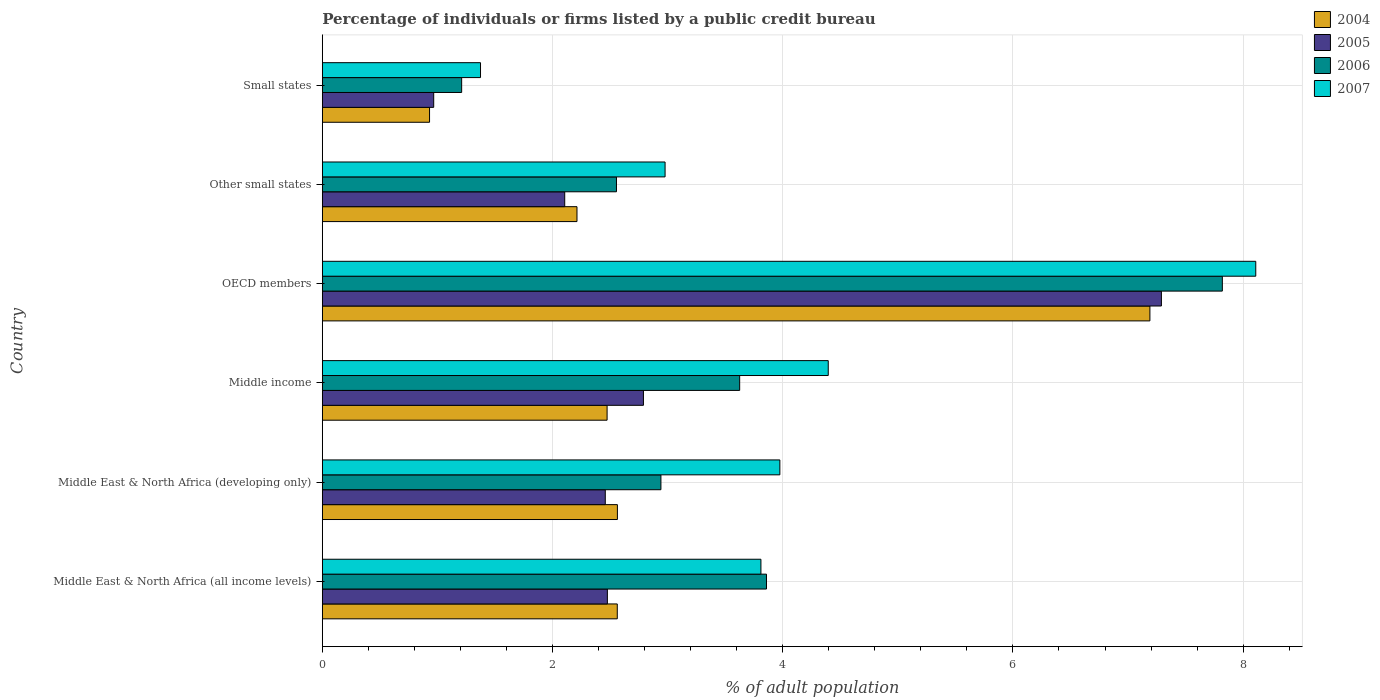How many different coloured bars are there?
Provide a short and direct response. 4. How many groups of bars are there?
Your answer should be compact. 6. Are the number of bars on each tick of the Y-axis equal?
Keep it short and to the point. Yes. How many bars are there on the 6th tick from the top?
Your response must be concise. 4. How many bars are there on the 4th tick from the bottom?
Provide a short and direct response. 4. In how many cases, is the number of bars for a given country not equal to the number of legend labels?
Make the answer very short. 0. What is the percentage of population listed by a public credit bureau in 2006 in Middle East & North Africa (all income levels)?
Give a very brief answer. 3.86. Across all countries, what is the maximum percentage of population listed by a public credit bureau in 2004?
Make the answer very short. 7.19. Across all countries, what is the minimum percentage of population listed by a public credit bureau in 2007?
Your answer should be very brief. 1.37. In which country was the percentage of population listed by a public credit bureau in 2007 maximum?
Offer a very short reply. OECD members. In which country was the percentage of population listed by a public credit bureau in 2005 minimum?
Provide a short and direct response. Small states. What is the total percentage of population listed by a public credit bureau in 2005 in the graph?
Your answer should be very brief. 18.09. What is the difference between the percentage of population listed by a public credit bureau in 2004 in Middle East & North Africa (all income levels) and that in Small states?
Keep it short and to the point. 1.63. What is the difference between the percentage of population listed by a public credit bureau in 2007 in Middle East & North Africa (all income levels) and the percentage of population listed by a public credit bureau in 2004 in Middle East & North Africa (developing only)?
Make the answer very short. 1.25. What is the average percentage of population listed by a public credit bureau in 2006 per country?
Your response must be concise. 3.67. What is the difference between the percentage of population listed by a public credit bureau in 2006 and percentage of population listed by a public credit bureau in 2007 in Small states?
Offer a very short reply. -0.16. What is the ratio of the percentage of population listed by a public credit bureau in 2005 in OECD members to that in Other small states?
Give a very brief answer. 3.46. Is the difference between the percentage of population listed by a public credit bureau in 2006 in Middle East & North Africa (all income levels) and Other small states greater than the difference between the percentage of population listed by a public credit bureau in 2007 in Middle East & North Africa (all income levels) and Other small states?
Provide a succinct answer. Yes. What is the difference between the highest and the second highest percentage of population listed by a public credit bureau in 2006?
Your response must be concise. 3.96. What is the difference between the highest and the lowest percentage of population listed by a public credit bureau in 2007?
Make the answer very short. 6.74. Is the sum of the percentage of population listed by a public credit bureau in 2006 in Middle income and OECD members greater than the maximum percentage of population listed by a public credit bureau in 2005 across all countries?
Offer a terse response. Yes. What does the 3rd bar from the bottom in Middle income represents?
Offer a terse response. 2006. Is it the case that in every country, the sum of the percentage of population listed by a public credit bureau in 2007 and percentage of population listed by a public credit bureau in 2005 is greater than the percentage of population listed by a public credit bureau in 2004?
Provide a succinct answer. Yes. Are all the bars in the graph horizontal?
Make the answer very short. Yes. What is the difference between two consecutive major ticks on the X-axis?
Provide a short and direct response. 2. Are the values on the major ticks of X-axis written in scientific E-notation?
Your answer should be very brief. No. Does the graph contain grids?
Make the answer very short. Yes. Where does the legend appear in the graph?
Offer a terse response. Top right. What is the title of the graph?
Provide a short and direct response. Percentage of individuals or firms listed by a public credit bureau. Does "1973" appear as one of the legend labels in the graph?
Offer a very short reply. No. What is the label or title of the X-axis?
Provide a succinct answer. % of adult population. What is the label or title of the Y-axis?
Your answer should be compact. Country. What is the % of adult population in 2004 in Middle East & North Africa (all income levels)?
Offer a very short reply. 2.56. What is the % of adult population in 2005 in Middle East & North Africa (all income levels)?
Keep it short and to the point. 2.48. What is the % of adult population of 2006 in Middle East & North Africa (all income levels)?
Offer a terse response. 3.86. What is the % of adult population in 2007 in Middle East & North Africa (all income levels)?
Give a very brief answer. 3.81. What is the % of adult population of 2004 in Middle East & North Africa (developing only)?
Ensure brevity in your answer.  2.56. What is the % of adult population of 2005 in Middle East & North Africa (developing only)?
Your answer should be compact. 2.46. What is the % of adult population in 2006 in Middle East & North Africa (developing only)?
Your answer should be very brief. 2.94. What is the % of adult population in 2007 in Middle East & North Africa (developing only)?
Your answer should be compact. 3.98. What is the % of adult population in 2004 in Middle income?
Your answer should be compact. 2.47. What is the % of adult population in 2005 in Middle income?
Offer a very short reply. 2.79. What is the % of adult population in 2006 in Middle income?
Keep it short and to the point. 3.63. What is the % of adult population of 2007 in Middle income?
Keep it short and to the point. 4.4. What is the % of adult population in 2004 in OECD members?
Your answer should be very brief. 7.19. What is the % of adult population of 2005 in OECD members?
Keep it short and to the point. 7.29. What is the % of adult population of 2006 in OECD members?
Your response must be concise. 7.82. What is the % of adult population in 2007 in OECD members?
Your answer should be compact. 8.11. What is the % of adult population of 2004 in Other small states?
Offer a terse response. 2.21. What is the % of adult population of 2005 in Other small states?
Provide a short and direct response. 2.11. What is the % of adult population in 2006 in Other small states?
Provide a succinct answer. 2.56. What is the % of adult population of 2007 in Other small states?
Provide a succinct answer. 2.98. What is the % of adult population in 2004 in Small states?
Give a very brief answer. 0.93. What is the % of adult population of 2005 in Small states?
Your response must be concise. 0.97. What is the % of adult population in 2006 in Small states?
Provide a succinct answer. 1.21. What is the % of adult population in 2007 in Small states?
Your response must be concise. 1.37. Across all countries, what is the maximum % of adult population of 2004?
Make the answer very short. 7.19. Across all countries, what is the maximum % of adult population of 2005?
Your answer should be compact. 7.29. Across all countries, what is the maximum % of adult population in 2006?
Your answer should be very brief. 7.82. Across all countries, what is the maximum % of adult population in 2007?
Keep it short and to the point. 8.11. Across all countries, what is the minimum % of adult population in 2004?
Offer a very short reply. 0.93. Across all countries, what is the minimum % of adult population of 2005?
Ensure brevity in your answer.  0.97. Across all countries, what is the minimum % of adult population in 2006?
Offer a terse response. 1.21. Across all countries, what is the minimum % of adult population in 2007?
Offer a very short reply. 1.37. What is the total % of adult population in 2004 in the graph?
Your answer should be compact. 17.93. What is the total % of adult population in 2005 in the graph?
Make the answer very short. 18.09. What is the total % of adult population in 2006 in the graph?
Provide a succinct answer. 22.01. What is the total % of adult population in 2007 in the graph?
Give a very brief answer. 24.64. What is the difference between the % of adult population of 2004 in Middle East & North Africa (all income levels) and that in Middle East & North Africa (developing only)?
Your answer should be compact. -0. What is the difference between the % of adult population in 2005 in Middle East & North Africa (all income levels) and that in Middle East & North Africa (developing only)?
Offer a terse response. 0.02. What is the difference between the % of adult population of 2006 in Middle East & North Africa (all income levels) and that in Middle East & North Africa (developing only)?
Provide a succinct answer. 0.92. What is the difference between the % of adult population in 2007 in Middle East & North Africa (all income levels) and that in Middle East & North Africa (developing only)?
Your answer should be very brief. -0.16. What is the difference between the % of adult population of 2004 in Middle East & North Africa (all income levels) and that in Middle income?
Keep it short and to the point. 0.09. What is the difference between the % of adult population in 2005 in Middle East & North Africa (all income levels) and that in Middle income?
Keep it short and to the point. -0.31. What is the difference between the % of adult population of 2006 in Middle East & North Africa (all income levels) and that in Middle income?
Provide a short and direct response. 0.23. What is the difference between the % of adult population in 2007 in Middle East & North Africa (all income levels) and that in Middle income?
Provide a succinct answer. -0.58. What is the difference between the % of adult population in 2004 in Middle East & North Africa (all income levels) and that in OECD members?
Provide a succinct answer. -4.63. What is the difference between the % of adult population in 2005 in Middle East & North Africa (all income levels) and that in OECD members?
Provide a short and direct response. -4.81. What is the difference between the % of adult population of 2006 in Middle East & North Africa (all income levels) and that in OECD members?
Provide a short and direct response. -3.96. What is the difference between the % of adult population in 2007 in Middle East & North Africa (all income levels) and that in OECD members?
Keep it short and to the point. -4.3. What is the difference between the % of adult population in 2004 in Middle East & North Africa (all income levels) and that in Other small states?
Your response must be concise. 0.35. What is the difference between the % of adult population of 2005 in Middle East & North Africa (all income levels) and that in Other small states?
Offer a very short reply. 0.37. What is the difference between the % of adult population in 2006 in Middle East & North Africa (all income levels) and that in Other small states?
Offer a terse response. 1.3. What is the difference between the % of adult population in 2007 in Middle East & North Africa (all income levels) and that in Other small states?
Provide a short and direct response. 0.83. What is the difference between the % of adult population of 2004 in Middle East & North Africa (all income levels) and that in Small states?
Offer a very short reply. 1.63. What is the difference between the % of adult population in 2005 in Middle East & North Africa (all income levels) and that in Small states?
Your response must be concise. 1.51. What is the difference between the % of adult population in 2006 in Middle East & North Africa (all income levels) and that in Small states?
Make the answer very short. 2.65. What is the difference between the % of adult population of 2007 in Middle East & North Africa (all income levels) and that in Small states?
Keep it short and to the point. 2.44. What is the difference between the % of adult population in 2004 in Middle East & North Africa (developing only) and that in Middle income?
Offer a very short reply. 0.09. What is the difference between the % of adult population in 2005 in Middle East & North Africa (developing only) and that in Middle income?
Offer a terse response. -0.33. What is the difference between the % of adult population in 2006 in Middle East & North Africa (developing only) and that in Middle income?
Keep it short and to the point. -0.68. What is the difference between the % of adult population in 2007 in Middle East & North Africa (developing only) and that in Middle income?
Keep it short and to the point. -0.42. What is the difference between the % of adult population of 2004 in Middle East & North Africa (developing only) and that in OECD members?
Make the answer very short. -4.63. What is the difference between the % of adult population of 2005 in Middle East & North Africa (developing only) and that in OECD members?
Offer a terse response. -4.83. What is the difference between the % of adult population of 2006 in Middle East & North Africa (developing only) and that in OECD members?
Make the answer very short. -4.88. What is the difference between the % of adult population of 2007 in Middle East & North Africa (developing only) and that in OECD members?
Ensure brevity in your answer.  -4.13. What is the difference between the % of adult population of 2004 in Middle East & North Africa (developing only) and that in Other small states?
Ensure brevity in your answer.  0.35. What is the difference between the % of adult population of 2005 in Middle East & North Africa (developing only) and that in Other small states?
Offer a very short reply. 0.35. What is the difference between the % of adult population of 2006 in Middle East & North Africa (developing only) and that in Other small states?
Keep it short and to the point. 0.39. What is the difference between the % of adult population of 2007 in Middle East & North Africa (developing only) and that in Other small states?
Provide a short and direct response. 1. What is the difference between the % of adult population of 2004 in Middle East & North Africa (developing only) and that in Small states?
Keep it short and to the point. 1.63. What is the difference between the % of adult population of 2005 in Middle East & North Africa (developing only) and that in Small states?
Give a very brief answer. 1.49. What is the difference between the % of adult population of 2006 in Middle East & North Africa (developing only) and that in Small states?
Provide a succinct answer. 1.73. What is the difference between the % of adult population of 2007 in Middle East & North Africa (developing only) and that in Small states?
Offer a terse response. 2.6. What is the difference between the % of adult population in 2004 in Middle income and that in OECD members?
Offer a terse response. -4.72. What is the difference between the % of adult population in 2005 in Middle income and that in OECD members?
Offer a terse response. -4.5. What is the difference between the % of adult population of 2006 in Middle income and that in OECD members?
Provide a succinct answer. -4.19. What is the difference between the % of adult population in 2007 in Middle income and that in OECD members?
Provide a short and direct response. -3.71. What is the difference between the % of adult population of 2004 in Middle income and that in Other small states?
Provide a succinct answer. 0.26. What is the difference between the % of adult population in 2005 in Middle income and that in Other small states?
Offer a terse response. 0.68. What is the difference between the % of adult population in 2006 in Middle income and that in Other small states?
Make the answer very short. 1.07. What is the difference between the % of adult population in 2007 in Middle income and that in Other small states?
Offer a very short reply. 1.42. What is the difference between the % of adult population in 2004 in Middle income and that in Small states?
Make the answer very short. 1.54. What is the difference between the % of adult population in 2005 in Middle income and that in Small states?
Make the answer very short. 1.82. What is the difference between the % of adult population of 2006 in Middle income and that in Small states?
Provide a succinct answer. 2.42. What is the difference between the % of adult population of 2007 in Middle income and that in Small states?
Offer a very short reply. 3.02. What is the difference between the % of adult population in 2004 in OECD members and that in Other small states?
Your response must be concise. 4.98. What is the difference between the % of adult population of 2005 in OECD members and that in Other small states?
Provide a short and direct response. 5.18. What is the difference between the % of adult population of 2006 in OECD members and that in Other small states?
Offer a very short reply. 5.26. What is the difference between the % of adult population of 2007 in OECD members and that in Other small states?
Offer a terse response. 5.13. What is the difference between the % of adult population of 2004 in OECD members and that in Small states?
Offer a very short reply. 6.26. What is the difference between the % of adult population of 2005 in OECD members and that in Small states?
Make the answer very short. 6.32. What is the difference between the % of adult population in 2006 in OECD members and that in Small states?
Your answer should be very brief. 6.61. What is the difference between the % of adult population of 2007 in OECD members and that in Small states?
Make the answer very short. 6.74. What is the difference between the % of adult population in 2004 in Other small states and that in Small states?
Offer a terse response. 1.28. What is the difference between the % of adult population of 2005 in Other small states and that in Small states?
Offer a very short reply. 1.14. What is the difference between the % of adult population in 2006 in Other small states and that in Small states?
Keep it short and to the point. 1.34. What is the difference between the % of adult population in 2007 in Other small states and that in Small states?
Provide a short and direct response. 1.6. What is the difference between the % of adult population of 2004 in Middle East & North Africa (all income levels) and the % of adult population of 2005 in Middle East & North Africa (developing only)?
Your response must be concise. 0.1. What is the difference between the % of adult population in 2004 in Middle East & North Africa (all income levels) and the % of adult population in 2006 in Middle East & North Africa (developing only)?
Ensure brevity in your answer.  -0.38. What is the difference between the % of adult population of 2004 in Middle East & North Africa (all income levels) and the % of adult population of 2007 in Middle East & North Africa (developing only)?
Keep it short and to the point. -1.41. What is the difference between the % of adult population in 2005 in Middle East & North Africa (all income levels) and the % of adult population in 2006 in Middle East & North Africa (developing only)?
Your answer should be compact. -0.47. What is the difference between the % of adult population of 2005 in Middle East & North Africa (all income levels) and the % of adult population of 2007 in Middle East & North Africa (developing only)?
Provide a short and direct response. -1.5. What is the difference between the % of adult population of 2006 in Middle East & North Africa (all income levels) and the % of adult population of 2007 in Middle East & North Africa (developing only)?
Provide a succinct answer. -0.12. What is the difference between the % of adult population of 2004 in Middle East & North Africa (all income levels) and the % of adult population of 2005 in Middle income?
Ensure brevity in your answer.  -0.23. What is the difference between the % of adult population in 2004 in Middle East & North Africa (all income levels) and the % of adult population in 2006 in Middle income?
Ensure brevity in your answer.  -1.06. What is the difference between the % of adult population of 2004 in Middle East & North Africa (all income levels) and the % of adult population of 2007 in Middle income?
Keep it short and to the point. -1.83. What is the difference between the % of adult population of 2005 in Middle East & North Africa (all income levels) and the % of adult population of 2006 in Middle income?
Make the answer very short. -1.15. What is the difference between the % of adult population in 2005 in Middle East & North Africa (all income levels) and the % of adult population in 2007 in Middle income?
Keep it short and to the point. -1.92. What is the difference between the % of adult population of 2006 in Middle East & North Africa (all income levels) and the % of adult population of 2007 in Middle income?
Keep it short and to the point. -0.54. What is the difference between the % of adult population in 2004 in Middle East & North Africa (all income levels) and the % of adult population in 2005 in OECD members?
Give a very brief answer. -4.73. What is the difference between the % of adult population of 2004 in Middle East & North Africa (all income levels) and the % of adult population of 2006 in OECD members?
Your answer should be compact. -5.26. What is the difference between the % of adult population of 2004 in Middle East & North Africa (all income levels) and the % of adult population of 2007 in OECD members?
Provide a short and direct response. -5.55. What is the difference between the % of adult population of 2005 in Middle East & North Africa (all income levels) and the % of adult population of 2006 in OECD members?
Provide a short and direct response. -5.34. What is the difference between the % of adult population in 2005 in Middle East & North Africa (all income levels) and the % of adult population in 2007 in OECD members?
Offer a terse response. -5.63. What is the difference between the % of adult population of 2006 in Middle East & North Africa (all income levels) and the % of adult population of 2007 in OECD members?
Your response must be concise. -4.25. What is the difference between the % of adult population of 2004 in Middle East & North Africa (all income levels) and the % of adult population of 2005 in Other small states?
Ensure brevity in your answer.  0.46. What is the difference between the % of adult population in 2004 in Middle East & North Africa (all income levels) and the % of adult population in 2006 in Other small states?
Your answer should be very brief. 0.01. What is the difference between the % of adult population of 2004 in Middle East & North Africa (all income levels) and the % of adult population of 2007 in Other small states?
Your answer should be very brief. -0.42. What is the difference between the % of adult population of 2005 in Middle East & North Africa (all income levels) and the % of adult population of 2006 in Other small states?
Your answer should be very brief. -0.08. What is the difference between the % of adult population of 2005 in Middle East & North Africa (all income levels) and the % of adult population of 2007 in Other small states?
Give a very brief answer. -0.5. What is the difference between the % of adult population of 2006 in Middle East & North Africa (all income levels) and the % of adult population of 2007 in Other small states?
Ensure brevity in your answer.  0.88. What is the difference between the % of adult population in 2004 in Middle East & North Africa (all income levels) and the % of adult population in 2005 in Small states?
Your response must be concise. 1.59. What is the difference between the % of adult population in 2004 in Middle East & North Africa (all income levels) and the % of adult population in 2006 in Small states?
Your answer should be very brief. 1.35. What is the difference between the % of adult population of 2004 in Middle East & North Africa (all income levels) and the % of adult population of 2007 in Small states?
Keep it short and to the point. 1.19. What is the difference between the % of adult population of 2005 in Middle East & North Africa (all income levels) and the % of adult population of 2006 in Small states?
Offer a very short reply. 1.27. What is the difference between the % of adult population of 2005 in Middle East & North Africa (all income levels) and the % of adult population of 2007 in Small states?
Offer a very short reply. 1.1. What is the difference between the % of adult population in 2006 in Middle East & North Africa (all income levels) and the % of adult population in 2007 in Small states?
Your response must be concise. 2.48. What is the difference between the % of adult population in 2004 in Middle East & North Africa (developing only) and the % of adult population in 2005 in Middle income?
Keep it short and to the point. -0.23. What is the difference between the % of adult population in 2004 in Middle East & North Africa (developing only) and the % of adult population in 2006 in Middle income?
Your answer should be compact. -1.06. What is the difference between the % of adult population in 2004 in Middle East & North Africa (developing only) and the % of adult population in 2007 in Middle income?
Provide a succinct answer. -1.83. What is the difference between the % of adult population in 2005 in Middle East & North Africa (developing only) and the % of adult population in 2006 in Middle income?
Your response must be concise. -1.17. What is the difference between the % of adult population of 2005 in Middle East & North Africa (developing only) and the % of adult population of 2007 in Middle income?
Offer a terse response. -1.94. What is the difference between the % of adult population of 2006 in Middle East & North Africa (developing only) and the % of adult population of 2007 in Middle income?
Your response must be concise. -1.45. What is the difference between the % of adult population of 2004 in Middle East & North Africa (developing only) and the % of adult population of 2005 in OECD members?
Provide a short and direct response. -4.73. What is the difference between the % of adult population in 2004 in Middle East & North Africa (developing only) and the % of adult population in 2006 in OECD members?
Your answer should be compact. -5.26. What is the difference between the % of adult population of 2004 in Middle East & North Africa (developing only) and the % of adult population of 2007 in OECD members?
Ensure brevity in your answer.  -5.55. What is the difference between the % of adult population of 2005 in Middle East & North Africa (developing only) and the % of adult population of 2006 in OECD members?
Keep it short and to the point. -5.36. What is the difference between the % of adult population of 2005 in Middle East & North Africa (developing only) and the % of adult population of 2007 in OECD members?
Make the answer very short. -5.65. What is the difference between the % of adult population in 2006 in Middle East & North Africa (developing only) and the % of adult population in 2007 in OECD members?
Provide a short and direct response. -5.17. What is the difference between the % of adult population in 2004 in Middle East & North Africa (developing only) and the % of adult population in 2005 in Other small states?
Make the answer very short. 0.46. What is the difference between the % of adult population of 2004 in Middle East & North Africa (developing only) and the % of adult population of 2006 in Other small states?
Ensure brevity in your answer.  0.01. What is the difference between the % of adult population of 2004 in Middle East & North Africa (developing only) and the % of adult population of 2007 in Other small states?
Offer a very short reply. -0.41. What is the difference between the % of adult population in 2005 in Middle East & North Africa (developing only) and the % of adult population in 2006 in Other small states?
Offer a terse response. -0.1. What is the difference between the % of adult population in 2005 in Middle East & North Africa (developing only) and the % of adult population in 2007 in Other small states?
Your response must be concise. -0.52. What is the difference between the % of adult population of 2006 in Middle East & North Africa (developing only) and the % of adult population of 2007 in Other small states?
Provide a succinct answer. -0.04. What is the difference between the % of adult population in 2004 in Middle East & North Africa (developing only) and the % of adult population in 2005 in Small states?
Offer a very short reply. 1.6. What is the difference between the % of adult population of 2004 in Middle East & North Africa (developing only) and the % of adult population of 2006 in Small states?
Offer a terse response. 1.35. What is the difference between the % of adult population in 2004 in Middle East & North Africa (developing only) and the % of adult population in 2007 in Small states?
Keep it short and to the point. 1.19. What is the difference between the % of adult population in 2005 in Middle East & North Africa (developing only) and the % of adult population in 2006 in Small states?
Provide a short and direct response. 1.25. What is the difference between the % of adult population of 2005 in Middle East & North Africa (developing only) and the % of adult population of 2007 in Small states?
Give a very brief answer. 1.08. What is the difference between the % of adult population of 2006 in Middle East & North Africa (developing only) and the % of adult population of 2007 in Small states?
Give a very brief answer. 1.57. What is the difference between the % of adult population of 2004 in Middle income and the % of adult population of 2005 in OECD members?
Give a very brief answer. -4.82. What is the difference between the % of adult population in 2004 in Middle income and the % of adult population in 2006 in OECD members?
Offer a very short reply. -5.35. What is the difference between the % of adult population of 2004 in Middle income and the % of adult population of 2007 in OECD members?
Provide a short and direct response. -5.64. What is the difference between the % of adult population in 2005 in Middle income and the % of adult population in 2006 in OECD members?
Your answer should be very brief. -5.03. What is the difference between the % of adult population of 2005 in Middle income and the % of adult population of 2007 in OECD members?
Your response must be concise. -5.32. What is the difference between the % of adult population in 2006 in Middle income and the % of adult population in 2007 in OECD members?
Provide a short and direct response. -4.48. What is the difference between the % of adult population of 2004 in Middle income and the % of adult population of 2005 in Other small states?
Your answer should be compact. 0.37. What is the difference between the % of adult population of 2004 in Middle income and the % of adult population of 2006 in Other small states?
Make the answer very short. -0.08. What is the difference between the % of adult population in 2004 in Middle income and the % of adult population in 2007 in Other small states?
Make the answer very short. -0.5. What is the difference between the % of adult population of 2005 in Middle income and the % of adult population of 2006 in Other small states?
Keep it short and to the point. 0.23. What is the difference between the % of adult population of 2005 in Middle income and the % of adult population of 2007 in Other small states?
Keep it short and to the point. -0.19. What is the difference between the % of adult population in 2006 in Middle income and the % of adult population in 2007 in Other small states?
Offer a terse response. 0.65. What is the difference between the % of adult population of 2004 in Middle income and the % of adult population of 2005 in Small states?
Keep it short and to the point. 1.51. What is the difference between the % of adult population of 2004 in Middle income and the % of adult population of 2006 in Small states?
Provide a succinct answer. 1.26. What is the difference between the % of adult population of 2004 in Middle income and the % of adult population of 2007 in Small states?
Give a very brief answer. 1.1. What is the difference between the % of adult population of 2005 in Middle income and the % of adult population of 2006 in Small states?
Ensure brevity in your answer.  1.58. What is the difference between the % of adult population in 2005 in Middle income and the % of adult population in 2007 in Small states?
Make the answer very short. 1.42. What is the difference between the % of adult population in 2006 in Middle income and the % of adult population in 2007 in Small states?
Your answer should be very brief. 2.25. What is the difference between the % of adult population in 2004 in OECD members and the % of adult population in 2005 in Other small states?
Offer a terse response. 5.08. What is the difference between the % of adult population in 2004 in OECD members and the % of adult population in 2006 in Other small states?
Provide a succinct answer. 4.63. What is the difference between the % of adult population of 2004 in OECD members and the % of adult population of 2007 in Other small states?
Ensure brevity in your answer.  4.21. What is the difference between the % of adult population in 2005 in OECD members and the % of adult population in 2006 in Other small states?
Provide a short and direct response. 4.73. What is the difference between the % of adult population of 2005 in OECD members and the % of adult population of 2007 in Other small states?
Give a very brief answer. 4.31. What is the difference between the % of adult population of 2006 in OECD members and the % of adult population of 2007 in Other small states?
Your answer should be compact. 4.84. What is the difference between the % of adult population in 2004 in OECD members and the % of adult population in 2005 in Small states?
Your response must be concise. 6.22. What is the difference between the % of adult population of 2004 in OECD members and the % of adult population of 2006 in Small states?
Ensure brevity in your answer.  5.98. What is the difference between the % of adult population of 2004 in OECD members and the % of adult population of 2007 in Small states?
Provide a succinct answer. 5.82. What is the difference between the % of adult population in 2005 in OECD members and the % of adult population in 2006 in Small states?
Your answer should be compact. 6.08. What is the difference between the % of adult population of 2005 in OECD members and the % of adult population of 2007 in Small states?
Provide a short and direct response. 5.92. What is the difference between the % of adult population in 2006 in OECD members and the % of adult population in 2007 in Small states?
Provide a succinct answer. 6.45. What is the difference between the % of adult population in 2004 in Other small states and the % of adult population in 2005 in Small states?
Your answer should be very brief. 1.24. What is the difference between the % of adult population in 2004 in Other small states and the % of adult population in 2006 in Small states?
Ensure brevity in your answer.  1. What is the difference between the % of adult population in 2004 in Other small states and the % of adult population in 2007 in Small states?
Provide a short and direct response. 0.84. What is the difference between the % of adult population of 2005 in Other small states and the % of adult population of 2006 in Small states?
Make the answer very short. 0.9. What is the difference between the % of adult population of 2005 in Other small states and the % of adult population of 2007 in Small states?
Ensure brevity in your answer.  0.73. What is the difference between the % of adult population of 2006 in Other small states and the % of adult population of 2007 in Small states?
Keep it short and to the point. 1.18. What is the average % of adult population of 2004 per country?
Give a very brief answer. 2.99. What is the average % of adult population in 2005 per country?
Provide a short and direct response. 3.01. What is the average % of adult population in 2006 per country?
Offer a very short reply. 3.67. What is the average % of adult population in 2007 per country?
Your answer should be compact. 4.11. What is the difference between the % of adult population of 2004 and % of adult population of 2005 in Middle East & North Africa (all income levels)?
Offer a terse response. 0.09. What is the difference between the % of adult population in 2004 and % of adult population in 2006 in Middle East & North Africa (all income levels)?
Provide a short and direct response. -1.3. What is the difference between the % of adult population of 2004 and % of adult population of 2007 in Middle East & North Africa (all income levels)?
Keep it short and to the point. -1.25. What is the difference between the % of adult population of 2005 and % of adult population of 2006 in Middle East & North Africa (all income levels)?
Provide a succinct answer. -1.38. What is the difference between the % of adult population in 2005 and % of adult population in 2007 in Middle East & North Africa (all income levels)?
Make the answer very short. -1.33. What is the difference between the % of adult population in 2006 and % of adult population in 2007 in Middle East & North Africa (all income levels)?
Keep it short and to the point. 0.05. What is the difference between the % of adult population of 2004 and % of adult population of 2005 in Middle East & North Africa (developing only)?
Your answer should be very brief. 0.11. What is the difference between the % of adult population in 2004 and % of adult population in 2006 in Middle East & North Africa (developing only)?
Provide a succinct answer. -0.38. What is the difference between the % of adult population in 2004 and % of adult population in 2007 in Middle East & North Africa (developing only)?
Keep it short and to the point. -1.41. What is the difference between the % of adult population in 2005 and % of adult population in 2006 in Middle East & North Africa (developing only)?
Offer a terse response. -0.48. What is the difference between the % of adult population in 2005 and % of adult population in 2007 in Middle East & North Africa (developing only)?
Provide a succinct answer. -1.52. What is the difference between the % of adult population of 2006 and % of adult population of 2007 in Middle East & North Africa (developing only)?
Offer a very short reply. -1.03. What is the difference between the % of adult population of 2004 and % of adult population of 2005 in Middle income?
Keep it short and to the point. -0.32. What is the difference between the % of adult population of 2004 and % of adult population of 2006 in Middle income?
Make the answer very short. -1.15. What is the difference between the % of adult population of 2004 and % of adult population of 2007 in Middle income?
Your answer should be compact. -1.92. What is the difference between the % of adult population in 2005 and % of adult population in 2006 in Middle income?
Provide a short and direct response. -0.84. What is the difference between the % of adult population in 2005 and % of adult population in 2007 in Middle income?
Ensure brevity in your answer.  -1.61. What is the difference between the % of adult population in 2006 and % of adult population in 2007 in Middle income?
Your answer should be very brief. -0.77. What is the difference between the % of adult population of 2004 and % of adult population of 2006 in OECD members?
Make the answer very short. -0.63. What is the difference between the % of adult population in 2004 and % of adult population in 2007 in OECD members?
Make the answer very short. -0.92. What is the difference between the % of adult population in 2005 and % of adult population in 2006 in OECD members?
Give a very brief answer. -0.53. What is the difference between the % of adult population of 2005 and % of adult population of 2007 in OECD members?
Offer a terse response. -0.82. What is the difference between the % of adult population in 2006 and % of adult population in 2007 in OECD members?
Give a very brief answer. -0.29. What is the difference between the % of adult population of 2004 and % of adult population of 2005 in Other small states?
Keep it short and to the point. 0.11. What is the difference between the % of adult population of 2004 and % of adult population of 2006 in Other small states?
Provide a short and direct response. -0.34. What is the difference between the % of adult population in 2004 and % of adult population in 2007 in Other small states?
Give a very brief answer. -0.77. What is the difference between the % of adult population of 2005 and % of adult population of 2006 in Other small states?
Your response must be concise. -0.45. What is the difference between the % of adult population of 2005 and % of adult population of 2007 in Other small states?
Ensure brevity in your answer.  -0.87. What is the difference between the % of adult population of 2006 and % of adult population of 2007 in Other small states?
Offer a terse response. -0.42. What is the difference between the % of adult population in 2004 and % of adult population in 2005 in Small states?
Ensure brevity in your answer.  -0.04. What is the difference between the % of adult population in 2004 and % of adult population in 2006 in Small states?
Your answer should be very brief. -0.28. What is the difference between the % of adult population in 2004 and % of adult population in 2007 in Small states?
Offer a terse response. -0.44. What is the difference between the % of adult population of 2005 and % of adult population of 2006 in Small states?
Provide a succinct answer. -0.24. What is the difference between the % of adult population of 2005 and % of adult population of 2007 in Small states?
Provide a succinct answer. -0.41. What is the difference between the % of adult population in 2006 and % of adult population in 2007 in Small states?
Keep it short and to the point. -0.16. What is the ratio of the % of adult population of 2004 in Middle East & North Africa (all income levels) to that in Middle East & North Africa (developing only)?
Give a very brief answer. 1. What is the ratio of the % of adult population in 2005 in Middle East & North Africa (all income levels) to that in Middle East & North Africa (developing only)?
Make the answer very short. 1.01. What is the ratio of the % of adult population in 2006 in Middle East & North Africa (all income levels) to that in Middle East & North Africa (developing only)?
Your response must be concise. 1.31. What is the ratio of the % of adult population in 2007 in Middle East & North Africa (all income levels) to that in Middle East & North Africa (developing only)?
Offer a very short reply. 0.96. What is the ratio of the % of adult population in 2004 in Middle East & North Africa (all income levels) to that in Middle income?
Ensure brevity in your answer.  1.04. What is the ratio of the % of adult population of 2005 in Middle East & North Africa (all income levels) to that in Middle income?
Provide a short and direct response. 0.89. What is the ratio of the % of adult population in 2006 in Middle East & North Africa (all income levels) to that in Middle income?
Give a very brief answer. 1.06. What is the ratio of the % of adult population of 2007 in Middle East & North Africa (all income levels) to that in Middle income?
Your response must be concise. 0.87. What is the ratio of the % of adult population of 2004 in Middle East & North Africa (all income levels) to that in OECD members?
Offer a terse response. 0.36. What is the ratio of the % of adult population in 2005 in Middle East & North Africa (all income levels) to that in OECD members?
Your answer should be very brief. 0.34. What is the ratio of the % of adult population in 2006 in Middle East & North Africa (all income levels) to that in OECD members?
Keep it short and to the point. 0.49. What is the ratio of the % of adult population in 2007 in Middle East & North Africa (all income levels) to that in OECD members?
Provide a short and direct response. 0.47. What is the ratio of the % of adult population of 2004 in Middle East & North Africa (all income levels) to that in Other small states?
Your answer should be very brief. 1.16. What is the ratio of the % of adult population in 2005 in Middle East & North Africa (all income levels) to that in Other small states?
Offer a terse response. 1.18. What is the ratio of the % of adult population in 2006 in Middle East & North Africa (all income levels) to that in Other small states?
Keep it short and to the point. 1.51. What is the ratio of the % of adult population of 2007 in Middle East & North Africa (all income levels) to that in Other small states?
Your answer should be very brief. 1.28. What is the ratio of the % of adult population of 2004 in Middle East & North Africa (all income levels) to that in Small states?
Your answer should be very brief. 2.75. What is the ratio of the % of adult population of 2005 in Middle East & North Africa (all income levels) to that in Small states?
Your response must be concise. 2.56. What is the ratio of the % of adult population of 2006 in Middle East & North Africa (all income levels) to that in Small states?
Your answer should be compact. 3.19. What is the ratio of the % of adult population of 2007 in Middle East & North Africa (all income levels) to that in Small states?
Your answer should be very brief. 2.77. What is the ratio of the % of adult population in 2004 in Middle East & North Africa (developing only) to that in Middle income?
Your answer should be very brief. 1.04. What is the ratio of the % of adult population of 2005 in Middle East & North Africa (developing only) to that in Middle income?
Your response must be concise. 0.88. What is the ratio of the % of adult population of 2006 in Middle East & North Africa (developing only) to that in Middle income?
Your answer should be compact. 0.81. What is the ratio of the % of adult population of 2007 in Middle East & North Africa (developing only) to that in Middle income?
Your answer should be compact. 0.9. What is the ratio of the % of adult population of 2004 in Middle East & North Africa (developing only) to that in OECD members?
Your response must be concise. 0.36. What is the ratio of the % of adult population in 2005 in Middle East & North Africa (developing only) to that in OECD members?
Provide a short and direct response. 0.34. What is the ratio of the % of adult population in 2006 in Middle East & North Africa (developing only) to that in OECD members?
Offer a very short reply. 0.38. What is the ratio of the % of adult population of 2007 in Middle East & North Africa (developing only) to that in OECD members?
Provide a succinct answer. 0.49. What is the ratio of the % of adult population of 2004 in Middle East & North Africa (developing only) to that in Other small states?
Your answer should be compact. 1.16. What is the ratio of the % of adult population of 2005 in Middle East & North Africa (developing only) to that in Other small states?
Ensure brevity in your answer.  1.17. What is the ratio of the % of adult population of 2006 in Middle East & North Africa (developing only) to that in Other small states?
Your response must be concise. 1.15. What is the ratio of the % of adult population in 2007 in Middle East & North Africa (developing only) to that in Other small states?
Provide a succinct answer. 1.33. What is the ratio of the % of adult population in 2004 in Middle East & North Africa (developing only) to that in Small states?
Your answer should be compact. 2.75. What is the ratio of the % of adult population of 2005 in Middle East & North Africa (developing only) to that in Small states?
Ensure brevity in your answer.  2.54. What is the ratio of the % of adult population in 2006 in Middle East & North Africa (developing only) to that in Small states?
Provide a succinct answer. 2.43. What is the ratio of the % of adult population of 2007 in Middle East & North Africa (developing only) to that in Small states?
Provide a succinct answer. 2.89. What is the ratio of the % of adult population of 2004 in Middle income to that in OECD members?
Your response must be concise. 0.34. What is the ratio of the % of adult population of 2005 in Middle income to that in OECD members?
Give a very brief answer. 0.38. What is the ratio of the % of adult population in 2006 in Middle income to that in OECD members?
Keep it short and to the point. 0.46. What is the ratio of the % of adult population of 2007 in Middle income to that in OECD members?
Ensure brevity in your answer.  0.54. What is the ratio of the % of adult population of 2004 in Middle income to that in Other small states?
Give a very brief answer. 1.12. What is the ratio of the % of adult population in 2005 in Middle income to that in Other small states?
Provide a short and direct response. 1.32. What is the ratio of the % of adult population of 2006 in Middle income to that in Other small states?
Provide a short and direct response. 1.42. What is the ratio of the % of adult population in 2007 in Middle income to that in Other small states?
Keep it short and to the point. 1.48. What is the ratio of the % of adult population in 2004 in Middle income to that in Small states?
Provide a short and direct response. 2.66. What is the ratio of the % of adult population of 2005 in Middle income to that in Small states?
Offer a terse response. 2.88. What is the ratio of the % of adult population of 2006 in Middle income to that in Small states?
Give a very brief answer. 3. What is the ratio of the % of adult population in 2007 in Middle income to that in Small states?
Your answer should be compact. 3.2. What is the ratio of the % of adult population in 2004 in OECD members to that in Other small states?
Your response must be concise. 3.25. What is the ratio of the % of adult population of 2005 in OECD members to that in Other small states?
Your answer should be compact. 3.46. What is the ratio of the % of adult population in 2006 in OECD members to that in Other small states?
Give a very brief answer. 3.06. What is the ratio of the % of adult population of 2007 in OECD members to that in Other small states?
Offer a very short reply. 2.72. What is the ratio of the % of adult population in 2004 in OECD members to that in Small states?
Keep it short and to the point. 7.72. What is the ratio of the % of adult population in 2005 in OECD members to that in Small states?
Ensure brevity in your answer.  7.53. What is the ratio of the % of adult population in 2006 in OECD members to that in Small states?
Give a very brief answer. 6.46. What is the ratio of the % of adult population in 2007 in OECD members to that in Small states?
Offer a terse response. 5.9. What is the ratio of the % of adult population of 2004 in Other small states to that in Small states?
Provide a short and direct response. 2.38. What is the ratio of the % of adult population of 2005 in Other small states to that in Small states?
Provide a short and direct response. 2.18. What is the ratio of the % of adult population of 2006 in Other small states to that in Small states?
Provide a short and direct response. 2.11. What is the ratio of the % of adult population in 2007 in Other small states to that in Small states?
Offer a very short reply. 2.17. What is the difference between the highest and the second highest % of adult population of 2004?
Your response must be concise. 4.63. What is the difference between the highest and the second highest % of adult population in 2005?
Offer a terse response. 4.5. What is the difference between the highest and the second highest % of adult population of 2006?
Give a very brief answer. 3.96. What is the difference between the highest and the second highest % of adult population of 2007?
Your response must be concise. 3.71. What is the difference between the highest and the lowest % of adult population in 2004?
Make the answer very short. 6.26. What is the difference between the highest and the lowest % of adult population in 2005?
Keep it short and to the point. 6.32. What is the difference between the highest and the lowest % of adult population of 2006?
Provide a succinct answer. 6.61. What is the difference between the highest and the lowest % of adult population in 2007?
Provide a short and direct response. 6.74. 